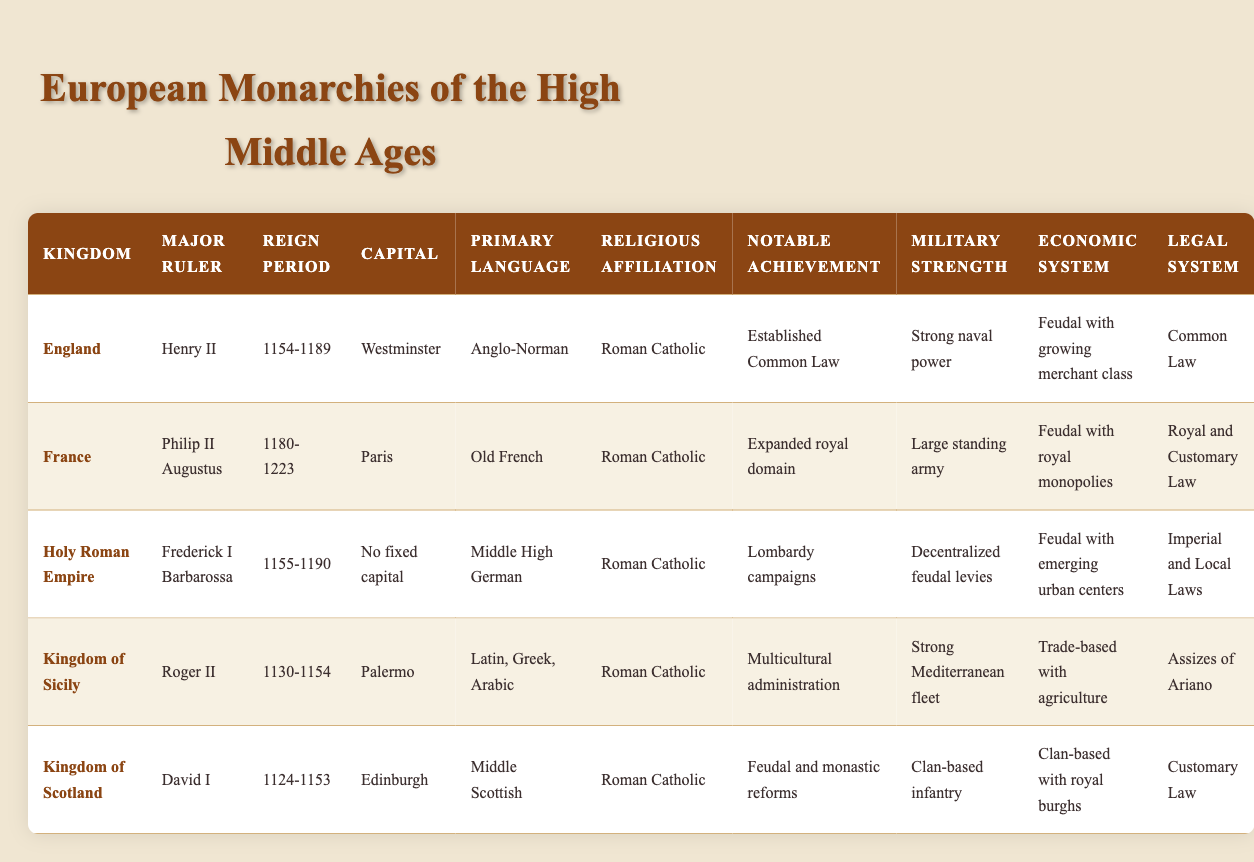What was the primary language spoken in the Kingdom of France? The primary language for the Kingdom of France, according to the table, is listed as Old French.
Answer: Old French Which kingdom had a major ruler that had a notable achievement of establishing Common Law? In the table, England is indicated to have Henry II as a major ruler, with the notable achievement of establishing Common Law.
Answer: England Did the Kingdom of Scotland practice a legal system based on Common Law? The table specifies that the Kingdom of Scotland utilized Customary Law, not Common Law. Therefore, the statement is false.
Answer: No Which kingdom had a strong Mediterranean fleet as part of its military strength? Referring to the table, the Kingdom of Sicily, under Roger II, is noted to have a strong Mediterranean fleet as its military strength.
Answer: Kingdom of Sicily What is the difference in reign period between Henry II of England and Philip II Augustus of France? Henry II reigned from 1154 to 1189, a total of 35 years, while Philip II Augustus reigned from 1180 to 1223, which is 43 years. The difference in their reign periods is 43 − 35 = 8 years.
Answer: 8 years Which Kingdom had a capital that was not fixed? The Holy Roman Empire is the only kingdom in the table that is noted for having no fixed capital.
Answer: Holy Roman Empire Which kingdoms were primarily Roman Catholic? By examining the religious affiliation in the table, all the kingdoms listed—England, France, Holy Roman Empire, Kingdom of Sicily, and Kingdom of Scotland—are affiliated with Roman Catholicism.
Answer: All listed kingdoms Identify the kingdom with the largest military strength based on the table description. The table cites France as having the largest military strength with a large standing army, in comparison to the other kingdoms' military strengths.
Answer: France What notable achievement is associated with the Holy Roman Empire? The table states that the Holy Roman Empire, under Frederick I Barbarossa, is notable for the Lombardy campaigns.
Answer: Lombardy campaigns 